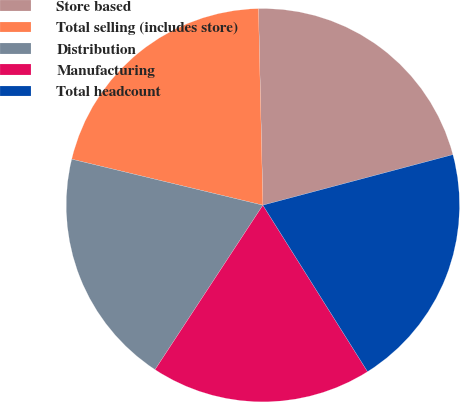<chart> <loc_0><loc_0><loc_500><loc_500><pie_chart><fcel>Store based<fcel>Total selling (includes store)<fcel>Distribution<fcel>Manufacturing<fcel>Total headcount<nl><fcel>21.22%<fcel>20.88%<fcel>19.52%<fcel>18.17%<fcel>20.2%<nl></chart> 